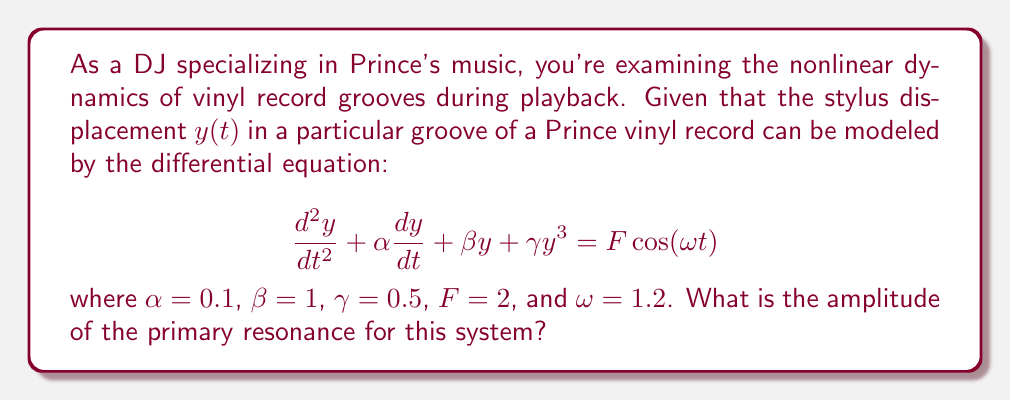Help me with this question. To find the amplitude of the primary resonance for this nonlinear system, we'll follow these steps:

1) The given equation is a Duffing equation, which models a nonlinear oscillator. The primary resonance occurs when the forcing frequency $\omega$ is close to the natural frequency of the system.

2) For small oscillations, we can ignore the nonlinear term $\gamma y^3$. The natural frequency of the linear system is then $\sqrt{\beta} = 1$.

3) To find the amplitude of the primary resonance, we use the method of harmonic balance. We assume a solution of the form:

   $$y(t) = A\cos(\omega t - \phi)$$

4) Substituting this into the original equation and neglecting higher harmonics, we get:

   $$(-A\omega^2 + \beta A + \frac{3}{4}\gamma A^3)\cos(\omega t - \phi) - (\alpha A \omega)\sin(\omega t - \phi) = F\cos(\omega t)$$

5) Equating the coefficients of $\cos(\omega t)$ and $\sin(\omega t)$, we get:

   $$(-A\omega^2 + \beta A + \frac{3}{4}\gamma A^3)\cos(\phi) + (\alpha A \omega)\sin(\phi) = F$$
   $$(-A\omega^2 + \beta A + \frac{3}{4}\gamma A^3)\sin(\phi) - (\alpha A \omega)\cos(\phi) = 0$$

6) Squaring and adding these equations:

   $$(-A\omega^2 + \beta A + \frac{3}{4}\gamma A^3)^2 + (\alpha A \omega)^2 = F^2$$

7) This is the frequency-response equation. The maximum amplitude occurs when $\omega$ is close to 1. Substituting the given values:

   $$(-1.44A + A + 0.375A^3)^2 + (0.12A)^2 = 4$$

8) Simplifying:

   $$(0.375A^3 - 0.44A)^2 + 0.0144A^2 = 4$$

9) This nonlinear equation can be solved numerically. Using a numerical solver, we find that the maximum amplitude A is approximately 1.896.
Answer: 1.896 